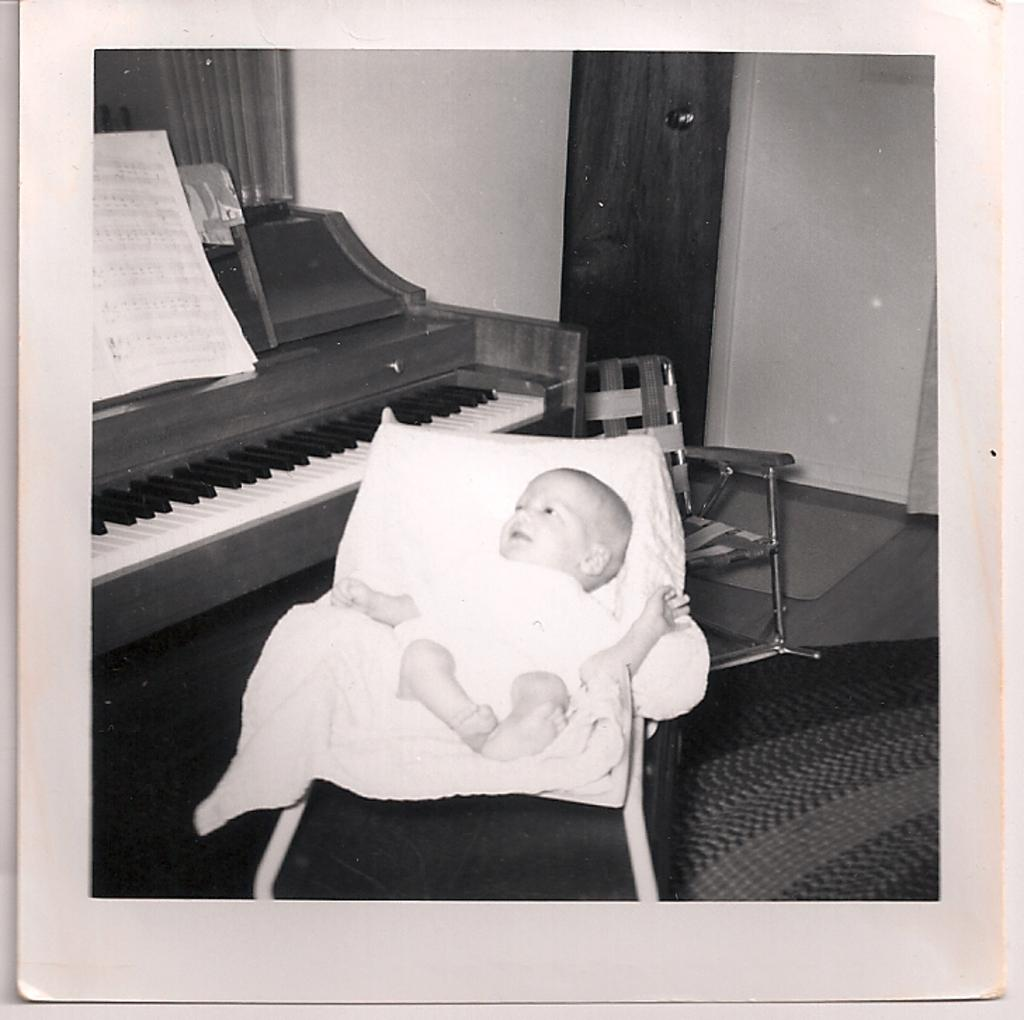What is the main subject of the image? There is a baby sitting on a chair in the center of the image. What can be seen in the background of the image? There is a keyboard, a paper, a chair, a door, a wall, and a curtain in the background. Can you describe the chair the baby is sitting on? The chair the baby is sitting on is in the center of the image. What might the baby be doing in the image? The baby might be playing with a toy or interacting with the keyboard in the background. What type of lumber is being used to construct the door in the image? There is no mention of lumber or the construction of the door in the image. The door is simply present in the background. How many rings can be seen on the baby's fingers in the image? There are no rings visible on the baby's fingers in the image. 